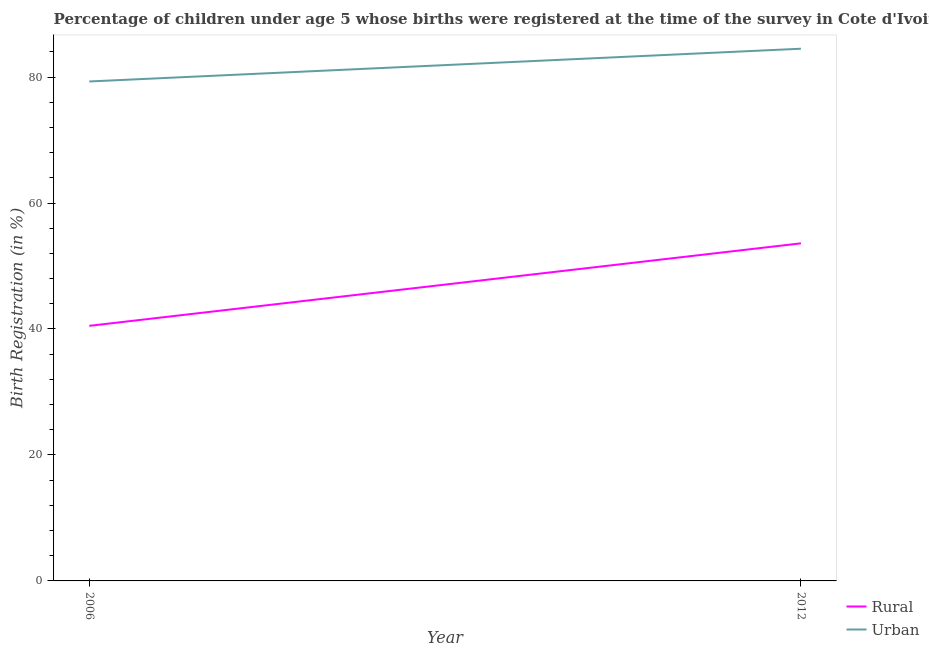Is the number of lines equal to the number of legend labels?
Your answer should be compact. Yes. What is the rural birth registration in 2012?
Offer a very short reply. 53.6. Across all years, what is the maximum rural birth registration?
Your answer should be very brief. 53.6. Across all years, what is the minimum rural birth registration?
Your answer should be very brief. 40.5. In which year was the urban birth registration maximum?
Offer a very short reply. 2012. In which year was the urban birth registration minimum?
Provide a short and direct response. 2006. What is the total urban birth registration in the graph?
Offer a very short reply. 163.8. What is the difference between the urban birth registration in 2006 and that in 2012?
Provide a succinct answer. -5.2. What is the difference between the rural birth registration in 2012 and the urban birth registration in 2006?
Offer a terse response. -25.7. What is the average rural birth registration per year?
Provide a short and direct response. 47.05. In the year 2006, what is the difference between the urban birth registration and rural birth registration?
Provide a short and direct response. 38.8. What is the ratio of the rural birth registration in 2006 to that in 2012?
Provide a succinct answer. 0.76. Is the urban birth registration in 2006 less than that in 2012?
Offer a terse response. Yes. In how many years, is the rural birth registration greater than the average rural birth registration taken over all years?
Your response must be concise. 1. Is the urban birth registration strictly less than the rural birth registration over the years?
Give a very brief answer. No. How many lines are there?
Make the answer very short. 2. How many years are there in the graph?
Your answer should be very brief. 2. Are the values on the major ticks of Y-axis written in scientific E-notation?
Ensure brevity in your answer.  No. What is the title of the graph?
Offer a very short reply. Percentage of children under age 5 whose births were registered at the time of the survey in Cote d'Ivoire. Does "Lowest 20% of population" appear as one of the legend labels in the graph?
Offer a terse response. No. What is the label or title of the X-axis?
Your answer should be very brief. Year. What is the label or title of the Y-axis?
Your response must be concise. Birth Registration (in %). What is the Birth Registration (in %) of Rural in 2006?
Offer a very short reply. 40.5. What is the Birth Registration (in %) of Urban in 2006?
Provide a short and direct response. 79.3. What is the Birth Registration (in %) of Rural in 2012?
Keep it short and to the point. 53.6. What is the Birth Registration (in %) of Urban in 2012?
Your answer should be compact. 84.5. Across all years, what is the maximum Birth Registration (in %) in Rural?
Give a very brief answer. 53.6. Across all years, what is the maximum Birth Registration (in %) of Urban?
Your response must be concise. 84.5. Across all years, what is the minimum Birth Registration (in %) of Rural?
Offer a terse response. 40.5. Across all years, what is the minimum Birth Registration (in %) of Urban?
Ensure brevity in your answer.  79.3. What is the total Birth Registration (in %) of Rural in the graph?
Offer a terse response. 94.1. What is the total Birth Registration (in %) in Urban in the graph?
Make the answer very short. 163.8. What is the difference between the Birth Registration (in %) in Rural in 2006 and that in 2012?
Give a very brief answer. -13.1. What is the difference between the Birth Registration (in %) of Rural in 2006 and the Birth Registration (in %) of Urban in 2012?
Keep it short and to the point. -44. What is the average Birth Registration (in %) of Rural per year?
Your response must be concise. 47.05. What is the average Birth Registration (in %) of Urban per year?
Keep it short and to the point. 81.9. In the year 2006, what is the difference between the Birth Registration (in %) of Rural and Birth Registration (in %) of Urban?
Offer a terse response. -38.8. In the year 2012, what is the difference between the Birth Registration (in %) in Rural and Birth Registration (in %) in Urban?
Your response must be concise. -30.9. What is the ratio of the Birth Registration (in %) of Rural in 2006 to that in 2012?
Provide a short and direct response. 0.76. What is the ratio of the Birth Registration (in %) of Urban in 2006 to that in 2012?
Ensure brevity in your answer.  0.94. What is the difference between the highest and the second highest Birth Registration (in %) in Rural?
Your response must be concise. 13.1. 